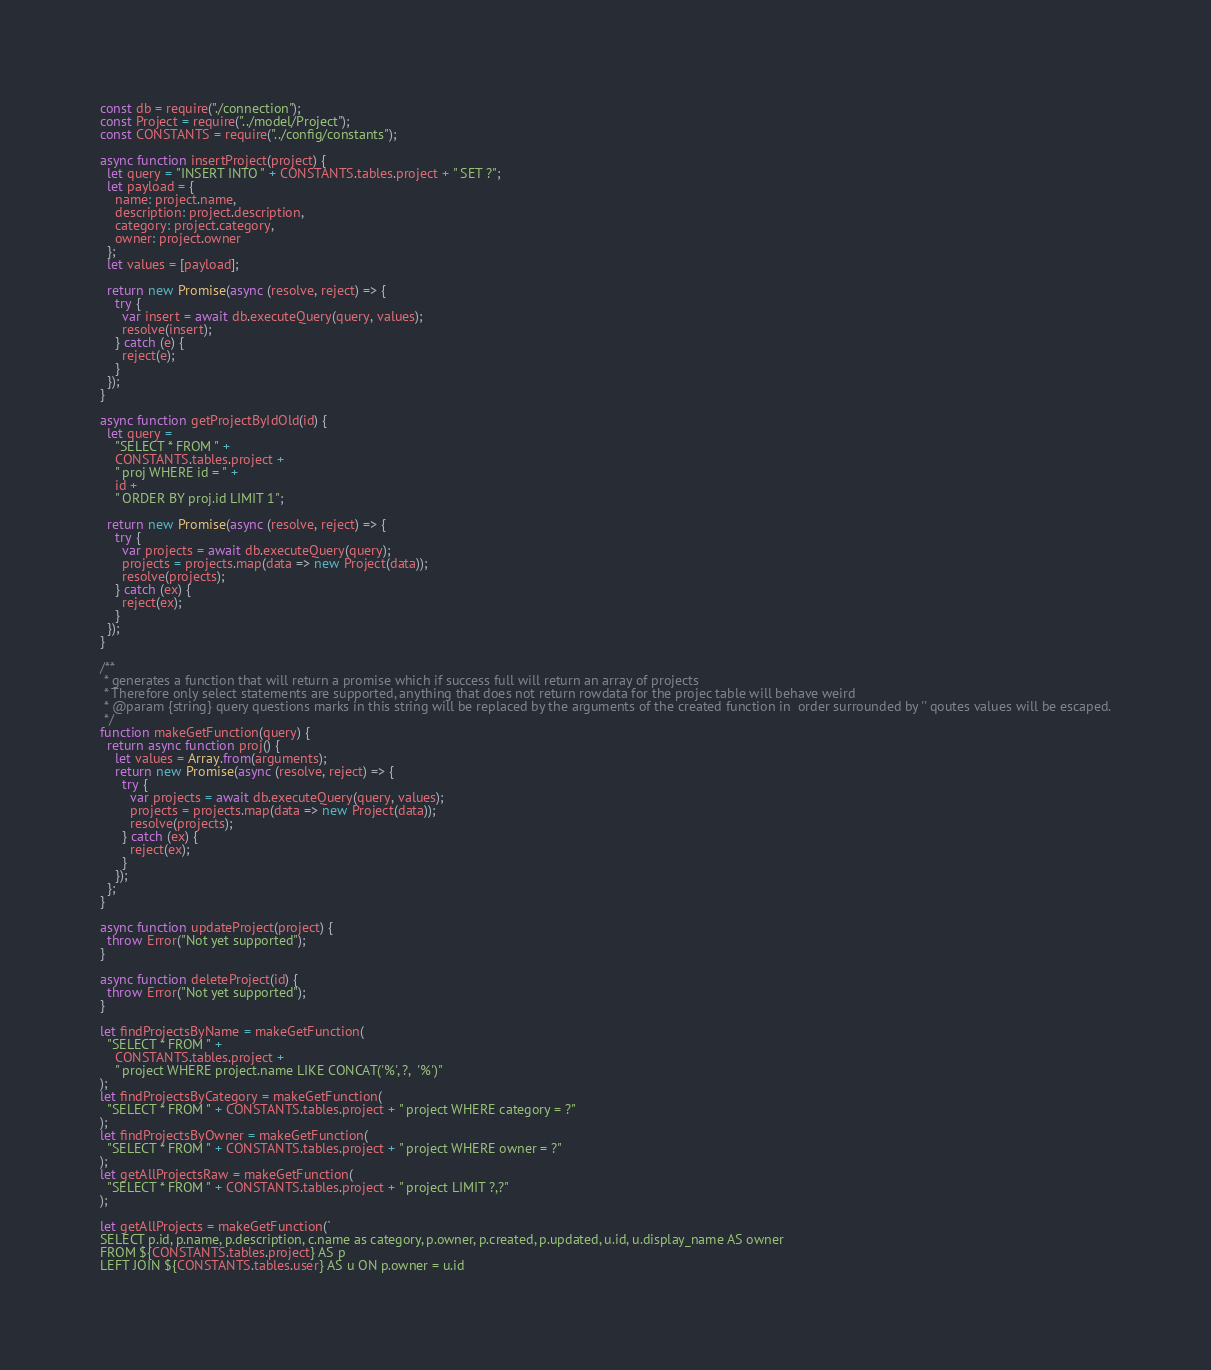<code> <loc_0><loc_0><loc_500><loc_500><_JavaScript_>const db = require("./connection");
const Project = require("../model/Project");
const CONSTANTS = require("../config/constants");

async function insertProject(project) {
  let query = "INSERT INTO " + CONSTANTS.tables.project + " SET ?";
  let payload = {
    name: project.name,
    description: project.description,
    category: project.category,
    owner: project.owner
  };
  let values = [payload];

  return new Promise(async (resolve, reject) => {
    try {
      var insert = await db.executeQuery(query, values);
      resolve(insert);
    } catch (e) {
      reject(e);
    }
  });
}

async function getProjectByIdOld(id) {
  let query =
    "SELECT * FROM " +
    CONSTANTS.tables.project +
    " proj WHERE id = " +
    id +
    " ORDER BY proj.id LIMIT 1";

  return new Promise(async (resolve, reject) => {
    try {
      var projects = await db.executeQuery(query);
      projects = projects.map(data => new Project(data));
      resolve(projects);
    } catch (ex) {
      reject(ex);
    }
  });
}

/**
 * generates a function that will return a promise which if success full will return an array of projects
 * Therefore only select statements are supported, anything that does not return rowdata for the projec table will behave weird
 * @param {string} query questions marks in this string will be replaced by the arguments of the created function in  order surrounded by '' qoutes values will be escaped.
 */
function makeGetFunction(query) {
  return async function proj() {
    let values = Array.from(arguments);
    return new Promise(async (resolve, reject) => {
      try {
        var projects = await db.executeQuery(query, values);
        projects = projects.map(data => new Project(data));
        resolve(projects);
      } catch (ex) {
        reject(ex);
      }
    });
  };
}

async function updateProject(project) {
  throw Error("Not yet supported");
}

async function deleteProject(id) {
  throw Error("Not yet supported");
}

let findProjectsByName = makeGetFunction(
  "SELECT * FROM " +
    CONSTANTS.tables.project +
    " project WHERE project.name LIKE CONCAT('%', ?,  '%')"
);
let findProjectsByCategory = makeGetFunction(
  "SELECT * FROM " + CONSTANTS.tables.project + " project WHERE category = ?"
);
let findProjectsByOwner = makeGetFunction(
  "SELECT * FROM " + CONSTANTS.tables.project + " project WHERE owner = ?"
);
let getAllProjectsRaw = makeGetFunction(
  "SELECT * FROM " + CONSTANTS.tables.project + " project LIMIT ?,?"
);

let getAllProjects = makeGetFunction(`
SELECT p.id, p.name, p.description, c.name as category, p.owner, p.created, p.updated, u.id, u.display_name AS owner 
FROM ${CONSTANTS.tables.project} AS p 
LEFT JOIN ${CONSTANTS.tables.user} AS u ON p.owner = u.id</code> 